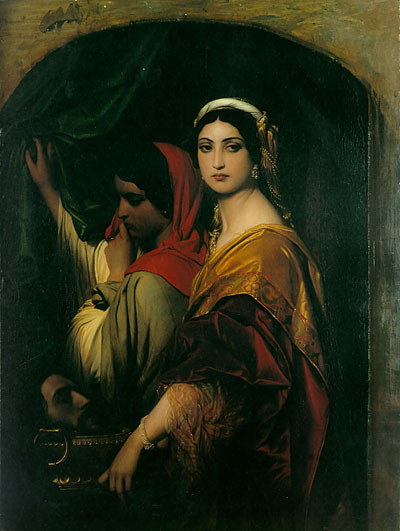What do you see happening in this image? The image showcases a compelling scene within a dark, arched alcove, strongly resembling the aesthetic of the Pre-Raphaelite movement. This art group famously valued intricate realism and themes inspired by medieval folklore. The painting features two women: one on the left, dressed in a vivid red shawl, delicately handling a green curtain. The other, to the right, wears an ornate robe adorned in hues of gold and red, with a white headpiece, emphasizing her regal demeanor. The contrasting vivid colors of their garments draw the viewer's gaze amidst the darker surrounding, highlighting their serene expressions and the intimate yet mysterious atmosphere typical of the era's artistic narratives. The dark arched setting further accentuates the vibrancy and detail of their dresses and accessories, reflecting the period's romantic and literary influences on visual arts. 